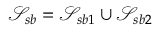<formula> <loc_0><loc_0><loc_500><loc_500>\mathcal { S } _ { s b } = \mathcal { S } _ { s b 1 } \cup \mathcal { S } _ { s b 2 }</formula> 